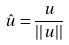Convert formula to latex. <formula><loc_0><loc_0><loc_500><loc_500>\hat { u } = \frac { u } { | | u | | }</formula> 